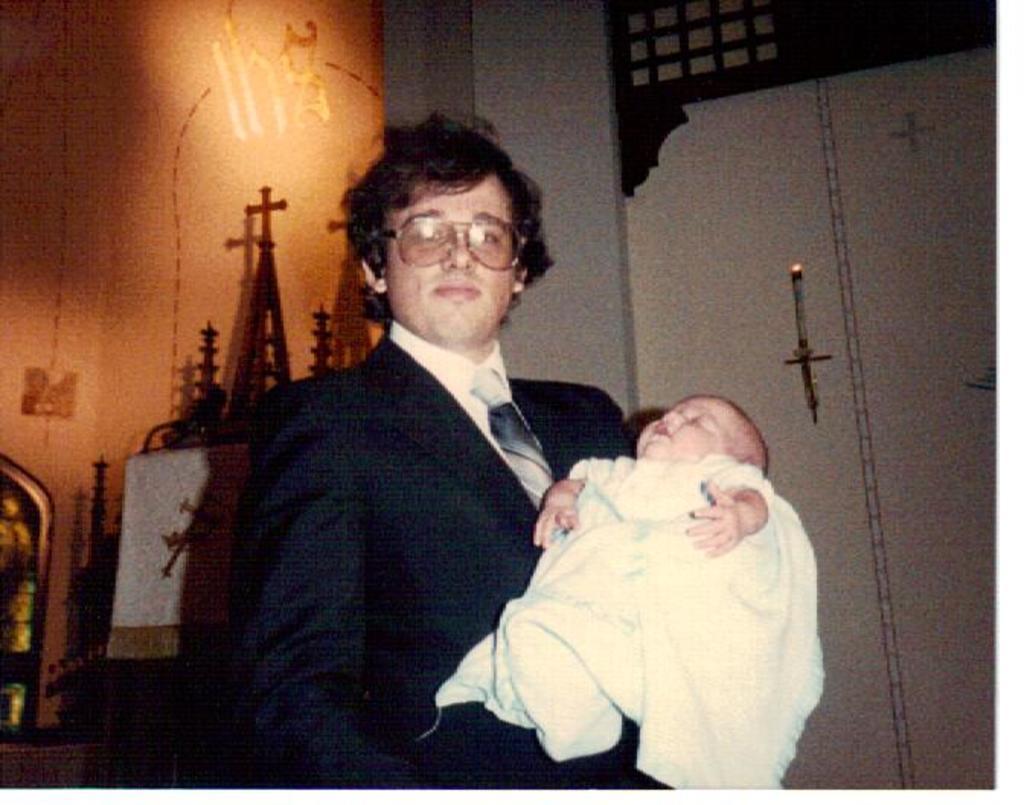Please provide a concise description of this image. In this image there is a person holding a baby in her arms. He is wearing a blazer, tie, spectacles. Behind him there is a shelf having few objects on it. Right side there is a candle which is on a shelf which is attached to the wall. Background there is a wall. 